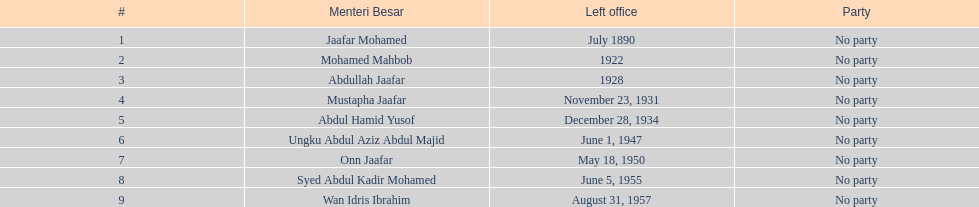Who took office after onn jaafar? Syed Abdul Kadir Mohamed. Give me the full table as a dictionary. {'header': ['#', 'Menteri Besar', 'Left office', 'Party'], 'rows': [['1', 'Jaafar Mohamed', 'July 1890', 'No party'], ['2', 'Mohamed Mahbob', '1922', 'No party'], ['3', 'Abdullah Jaafar', '1928', 'No party'], ['4', 'Mustapha Jaafar', 'November 23, 1931', 'No party'], ['5', 'Abdul Hamid Yusof', 'December 28, 1934', 'No party'], ['6', 'Ungku Abdul Aziz Abdul Majid', 'June 1, 1947', 'No party'], ['7', 'Onn Jaafar', 'May 18, 1950', 'No party'], ['8', 'Syed Abdul Kadir Mohamed', 'June 5, 1955', 'No party'], ['9', 'Wan Idris Ibrahim', 'August 31, 1957', 'No party']]} 